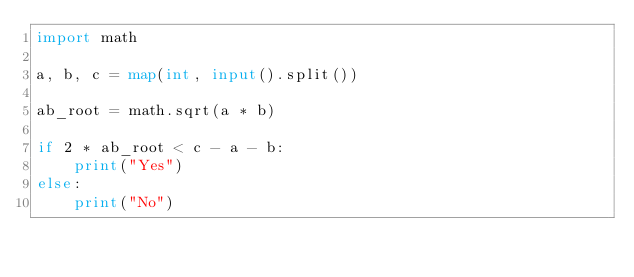<code> <loc_0><loc_0><loc_500><loc_500><_Python_>import math

a, b, c = map(int, input().split())

ab_root = math.sqrt(a * b)

if 2 * ab_root < c - a - b:
    print("Yes")
else:
    print("No")</code> 